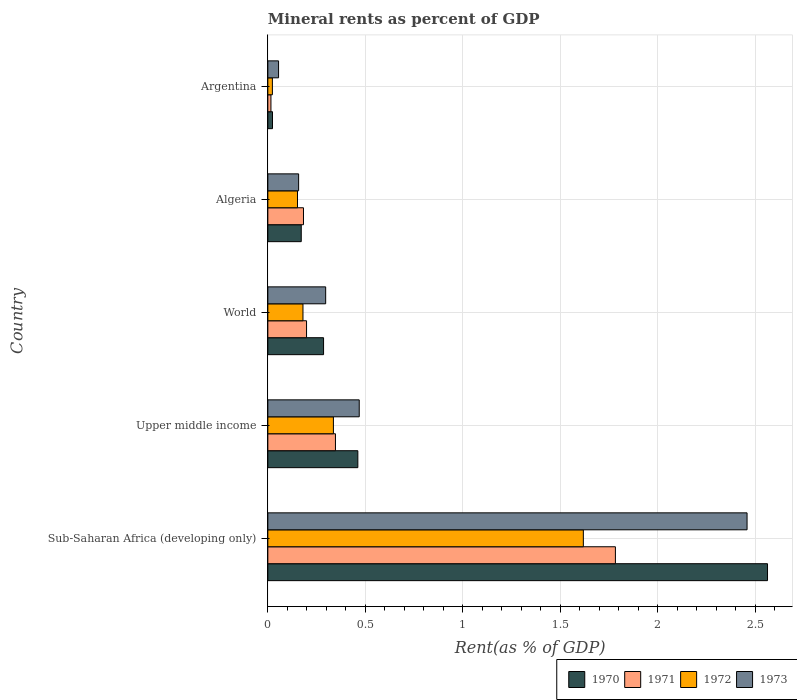How many groups of bars are there?
Your answer should be compact. 5. Are the number of bars per tick equal to the number of legend labels?
Your response must be concise. Yes. How many bars are there on the 5th tick from the top?
Keep it short and to the point. 4. How many bars are there on the 2nd tick from the bottom?
Ensure brevity in your answer.  4. What is the label of the 4th group of bars from the top?
Ensure brevity in your answer.  Upper middle income. What is the mineral rent in 1971 in Sub-Saharan Africa (developing only)?
Your answer should be very brief. 1.78. Across all countries, what is the maximum mineral rent in 1972?
Offer a terse response. 1.62. Across all countries, what is the minimum mineral rent in 1971?
Ensure brevity in your answer.  0.02. In which country was the mineral rent in 1972 maximum?
Give a very brief answer. Sub-Saharan Africa (developing only). In which country was the mineral rent in 1972 minimum?
Provide a succinct answer. Argentina. What is the total mineral rent in 1970 in the graph?
Your answer should be compact. 3.51. What is the difference between the mineral rent in 1971 in Argentina and that in Upper middle income?
Offer a terse response. -0.33. What is the difference between the mineral rent in 1973 in Argentina and the mineral rent in 1971 in World?
Keep it short and to the point. -0.14. What is the average mineral rent in 1970 per country?
Provide a succinct answer. 0.7. What is the difference between the mineral rent in 1972 and mineral rent in 1971 in Argentina?
Keep it short and to the point. 0.01. In how many countries, is the mineral rent in 1970 greater than 1.4 %?
Give a very brief answer. 1. What is the ratio of the mineral rent in 1972 in Sub-Saharan Africa (developing only) to that in Upper middle income?
Offer a very short reply. 4.81. What is the difference between the highest and the second highest mineral rent in 1973?
Offer a very short reply. 1.99. What is the difference between the highest and the lowest mineral rent in 1971?
Make the answer very short. 1.77. Is the sum of the mineral rent in 1973 in Algeria and World greater than the maximum mineral rent in 1972 across all countries?
Ensure brevity in your answer.  No. Is it the case that in every country, the sum of the mineral rent in 1973 and mineral rent in 1971 is greater than the sum of mineral rent in 1972 and mineral rent in 1970?
Provide a short and direct response. No. How many bars are there?
Your response must be concise. 20. Are all the bars in the graph horizontal?
Your response must be concise. Yes. How many countries are there in the graph?
Keep it short and to the point. 5. What is the difference between two consecutive major ticks on the X-axis?
Provide a short and direct response. 0.5. Are the values on the major ticks of X-axis written in scientific E-notation?
Give a very brief answer. No. Where does the legend appear in the graph?
Ensure brevity in your answer.  Bottom right. How many legend labels are there?
Your answer should be very brief. 4. What is the title of the graph?
Offer a terse response. Mineral rents as percent of GDP. What is the label or title of the X-axis?
Your answer should be compact. Rent(as % of GDP). What is the Rent(as % of GDP) of 1970 in Sub-Saharan Africa (developing only)?
Offer a terse response. 2.56. What is the Rent(as % of GDP) of 1971 in Sub-Saharan Africa (developing only)?
Provide a succinct answer. 1.78. What is the Rent(as % of GDP) in 1972 in Sub-Saharan Africa (developing only)?
Offer a terse response. 1.62. What is the Rent(as % of GDP) in 1973 in Sub-Saharan Africa (developing only)?
Offer a very short reply. 2.46. What is the Rent(as % of GDP) of 1970 in Upper middle income?
Offer a very short reply. 0.46. What is the Rent(as % of GDP) in 1971 in Upper middle income?
Your answer should be very brief. 0.35. What is the Rent(as % of GDP) of 1972 in Upper middle income?
Your answer should be very brief. 0.34. What is the Rent(as % of GDP) in 1973 in Upper middle income?
Provide a succinct answer. 0.47. What is the Rent(as % of GDP) in 1970 in World?
Offer a very short reply. 0.29. What is the Rent(as % of GDP) of 1971 in World?
Offer a very short reply. 0.2. What is the Rent(as % of GDP) of 1972 in World?
Make the answer very short. 0.18. What is the Rent(as % of GDP) of 1973 in World?
Offer a terse response. 0.3. What is the Rent(as % of GDP) of 1970 in Algeria?
Keep it short and to the point. 0.17. What is the Rent(as % of GDP) in 1971 in Algeria?
Your answer should be very brief. 0.18. What is the Rent(as % of GDP) in 1972 in Algeria?
Give a very brief answer. 0.15. What is the Rent(as % of GDP) in 1973 in Algeria?
Make the answer very short. 0.16. What is the Rent(as % of GDP) in 1970 in Argentina?
Your answer should be very brief. 0.02. What is the Rent(as % of GDP) in 1971 in Argentina?
Offer a very short reply. 0.02. What is the Rent(as % of GDP) of 1972 in Argentina?
Make the answer very short. 0.02. What is the Rent(as % of GDP) in 1973 in Argentina?
Keep it short and to the point. 0.06. Across all countries, what is the maximum Rent(as % of GDP) in 1970?
Make the answer very short. 2.56. Across all countries, what is the maximum Rent(as % of GDP) of 1971?
Provide a short and direct response. 1.78. Across all countries, what is the maximum Rent(as % of GDP) of 1972?
Keep it short and to the point. 1.62. Across all countries, what is the maximum Rent(as % of GDP) in 1973?
Keep it short and to the point. 2.46. Across all countries, what is the minimum Rent(as % of GDP) in 1970?
Your answer should be very brief. 0.02. Across all countries, what is the minimum Rent(as % of GDP) of 1971?
Ensure brevity in your answer.  0.02. Across all countries, what is the minimum Rent(as % of GDP) of 1972?
Your response must be concise. 0.02. Across all countries, what is the minimum Rent(as % of GDP) in 1973?
Your answer should be very brief. 0.06. What is the total Rent(as % of GDP) in 1970 in the graph?
Keep it short and to the point. 3.51. What is the total Rent(as % of GDP) in 1971 in the graph?
Your answer should be compact. 2.53. What is the total Rent(as % of GDP) of 1972 in the graph?
Provide a succinct answer. 2.31. What is the total Rent(as % of GDP) of 1973 in the graph?
Offer a terse response. 3.44. What is the difference between the Rent(as % of GDP) of 1970 in Sub-Saharan Africa (developing only) and that in Upper middle income?
Give a very brief answer. 2.1. What is the difference between the Rent(as % of GDP) in 1971 in Sub-Saharan Africa (developing only) and that in Upper middle income?
Offer a terse response. 1.44. What is the difference between the Rent(as % of GDP) in 1972 in Sub-Saharan Africa (developing only) and that in Upper middle income?
Give a very brief answer. 1.28. What is the difference between the Rent(as % of GDP) in 1973 in Sub-Saharan Africa (developing only) and that in Upper middle income?
Offer a very short reply. 1.99. What is the difference between the Rent(as % of GDP) in 1970 in Sub-Saharan Africa (developing only) and that in World?
Give a very brief answer. 2.28. What is the difference between the Rent(as % of GDP) in 1971 in Sub-Saharan Africa (developing only) and that in World?
Give a very brief answer. 1.58. What is the difference between the Rent(as % of GDP) in 1972 in Sub-Saharan Africa (developing only) and that in World?
Your response must be concise. 1.44. What is the difference between the Rent(as % of GDP) of 1973 in Sub-Saharan Africa (developing only) and that in World?
Offer a very short reply. 2.16. What is the difference between the Rent(as % of GDP) of 1970 in Sub-Saharan Africa (developing only) and that in Algeria?
Offer a terse response. 2.39. What is the difference between the Rent(as % of GDP) in 1971 in Sub-Saharan Africa (developing only) and that in Algeria?
Ensure brevity in your answer.  1.6. What is the difference between the Rent(as % of GDP) in 1972 in Sub-Saharan Africa (developing only) and that in Algeria?
Ensure brevity in your answer.  1.47. What is the difference between the Rent(as % of GDP) in 1973 in Sub-Saharan Africa (developing only) and that in Algeria?
Offer a very short reply. 2.3. What is the difference between the Rent(as % of GDP) of 1970 in Sub-Saharan Africa (developing only) and that in Argentina?
Offer a very short reply. 2.54. What is the difference between the Rent(as % of GDP) in 1971 in Sub-Saharan Africa (developing only) and that in Argentina?
Keep it short and to the point. 1.77. What is the difference between the Rent(as % of GDP) in 1972 in Sub-Saharan Africa (developing only) and that in Argentina?
Your answer should be compact. 1.6. What is the difference between the Rent(as % of GDP) in 1973 in Sub-Saharan Africa (developing only) and that in Argentina?
Offer a terse response. 2.4. What is the difference between the Rent(as % of GDP) in 1970 in Upper middle income and that in World?
Provide a short and direct response. 0.18. What is the difference between the Rent(as % of GDP) of 1971 in Upper middle income and that in World?
Your answer should be very brief. 0.15. What is the difference between the Rent(as % of GDP) of 1972 in Upper middle income and that in World?
Keep it short and to the point. 0.16. What is the difference between the Rent(as % of GDP) of 1973 in Upper middle income and that in World?
Your answer should be very brief. 0.17. What is the difference between the Rent(as % of GDP) of 1970 in Upper middle income and that in Algeria?
Ensure brevity in your answer.  0.29. What is the difference between the Rent(as % of GDP) in 1971 in Upper middle income and that in Algeria?
Your answer should be very brief. 0.16. What is the difference between the Rent(as % of GDP) of 1972 in Upper middle income and that in Algeria?
Your answer should be compact. 0.18. What is the difference between the Rent(as % of GDP) in 1973 in Upper middle income and that in Algeria?
Your answer should be compact. 0.31. What is the difference between the Rent(as % of GDP) in 1970 in Upper middle income and that in Argentina?
Your response must be concise. 0.44. What is the difference between the Rent(as % of GDP) in 1971 in Upper middle income and that in Argentina?
Provide a succinct answer. 0.33. What is the difference between the Rent(as % of GDP) of 1972 in Upper middle income and that in Argentina?
Ensure brevity in your answer.  0.31. What is the difference between the Rent(as % of GDP) of 1973 in Upper middle income and that in Argentina?
Provide a succinct answer. 0.41. What is the difference between the Rent(as % of GDP) in 1970 in World and that in Algeria?
Make the answer very short. 0.11. What is the difference between the Rent(as % of GDP) of 1971 in World and that in Algeria?
Keep it short and to the point. 0.02. What is the difference between the Rent(as % of GDP) in 1972 in World and that in Algeria?
Provide a short and direct response. 0.03. What is the difference between the Rent(as % of GDP) of 1973 in World and that in Algeria?
Make the answer very short. 0.14. What is the difference between the Rent(as % of GDP) of 1970 in World and that in Argentina?
Your response must be concise. 0.26. What is the difference between the Rent(as % of GDP) of 1971 in World and that in Argentina?
Offer a very short reply. 0.18. What is the difference between the Rent(as % of GDP) of 1972 in World and that in Argentina?
Offer a terse response. 0.16. What is the difference between the Rent(as % of GDP) of 1973 in World and that in Argentina?
Make the answer very short. 0.24. What is the difference between the Rent(as % of GDP) in 1970 in Algeria and that in Argentina?
Your answer should be very brief. 0.15. What is the difference between the Rent(as % of GDP) in 1971 in Algeria and that in Argentina?
Ensure brevity in your answer.  0.17. What is the difference between the Rent(as % of GDP) of 1972 in Algeria and that in Argentina?
Provide a short and direct response. 0.13. What is the difference between the Rent(as % of GDP) of 1973 in Algeria and that in Argentina?
Your answer should be compact. 0.1. What is the difference between the Rent(as % of GDP) in 1970 in Sub-Saharan Africa (developing only) and the Rent(as % of GDP) in 1971 in Upper middle income?
Your answer should be compact. 2.22. What is the difference between the Rent(as % of GDP) in 1970 in Sub-Saharan Africa (developing only) and the Rent(as % of GDP) in 1972 in Upper middle income?
Provide a succinct answer. 2.23. What is the difference between the Rent(as % of GDP) of 1970 in Sub-Saharan Africa (developing only) and the Rent(as % of GDP) of 1973 in Upper middle income?
Offer a very short reply. 2.1. What is the difference between the Rent(as % of GDP) in 1971 in Sub-Saharan Africa (developing only) and the Rent(as % of GDP) in 1972 in Upper middle income?
Provide a short and direct response. 1.45. What is the difference between the Rent(as % of GDP) of 1971 in Sub-Saharan Africa (developing only) and the Rent(as % of GDP) of 1973 in Upper middle income?
Your response must be concise. 1.31. What is the difference between the Rent(as % of GDP) in 1972 in Sub-Saharan Africa (developing only) and the Rent(as % of GDP) in 1973 in Upper middle income?
Ensure brevity in your answer.  1.15. What is the difference between the Rent(as % of GDP) in 1970 in Sub-Saharan Africa (developing only) and the Rent(as % of GDP) in 1971 in World?
Your answer should be compact. 2.37. What is the difference between the Rent(as % of GDP) of 1970 in Sub-Saharan Africa (developing only) and the Rent(as % of GDP) of 1972 in World?
Provide a succinct answer. 2.38. What is the difference between the Rent(as % of GDP) of 1970 in Sub-Saharan Africa (developing only) and the Rent(as % of GDP) of 1973 in World?
Provide a short and direct response. 2.27. What is the difference between the Rent(as % of GDP) of 1971 in Sub-Saharan Africa (developing only) and the Rent(as % of GDP) of 1972 in World?
Offer a very short reply. 1.6. What is the difference between the Rent(as % of GDP) in 1971 in Sub-Saharan Africa (developing only) and the Rent(as % of GDP) in 1973 in World?
Your answer should be compact. 1.49. What is the difference between the Rent(as % of GDP) of 1972 in Sub-Saharan Africa (developing only) and the Rent(as % of GDP) of 1973 in World?
Give a very brief answer. 1.32. What is the difference between the Rent(as % of GDP) in 1970 in Sub-Saharan Africa (developing only) and the Rent(as % of GDP) in 1971 in Algeria?
Make the answer very short. 2.38. What is the difference between the Rent(as % of GDP) in 1970 in Sub-Saharan Africa (developing only) and the Rent(as % of GDP) in 1972 in Algeria?
Offer a very short reply. 2.41. What is the difference between the Rent(as % of GDP) of 1970 in Sub-Saharan Africa (developing only) and the Rent(as % of GDP) of 1973 in Algeria?
Offer a terse response. 2.41. What is the difference between the Rent(as % of GDP) in 1971 in Sub-Saharan Africa (developing only) and the Rent(as % of GDP) in 1972 in Algeria?
Your answer should be very brief. 1.63. What is the difference between the Rent(as % of GDP) in 1971 in Sub-Saharan Africa (developing only) and the Rent(as % of GDP) in 1973 in Algeria?
Your answer should be very brief. 1.63. What is the difference between the Rent(as % of GDP) of 1972 in Sub-Saharan Africa (developing only) and the Rent(as % of GDP) of 1973 in Algeria?
Keep it short and to the point. 1.46. What is the difference between the Rent(as % of GDP) in 1970 in Sub-Saharan Africa (developing only) and the Rent(as % of GDP) in 1971 in Argentina?
Your answer should be compact. 2.55. What is the difference between the Rent(as % of GDP) of 1970 in Sub-Saharan Africa (developing only) and the Rent(as % of GDP) of 1972 in Argentina?
Provide a succinct answer. 2.54. What is the difference between the Rent(as % of GDP) in 1970 in Sub-Saharan Africa (developing only) and the Rent(as % of GDP) in 1973 in Argentina?
Provide a succinct answer. 2.51. What is the difference between the Rent(as % of GDP) of 1971 in Sub-Saharan Africa (developing only) and the Rent(as % of GDP) of 1972 in Argentina?
Your answer should be very brief. 1.76. What is the difference between the Rent(as % of GDP) of 1971 in Sub-Saharan Africa (developing only) and the Rent(as % of GDP) of 1973 in Argentina?
Offer a very short reply. 1.73. What is the difference between the Rent(as % of GDP) in 1972 in Sub-Saharan Africa (developing only) and the Rent(as % of GDP) in 1973 in Argentina?
Give a very brief answer. 1.56. What is the difference between the Rent(as % of GDP) of 1970 in Upper middle income and the Rent(as % of GDP) of 1971 in World?
Provide a short and direct response. 0.26. What is the difference between the Rent(as % of GDP) of 1970 in Upper middle income and the Rent(as % of GDP) of 1972 in World?
Provide a succinct answer. 0.28. What is the difference between the Rent(as % of GDP) of 1970 in Upper middle income and the Rent(as % of GDP) of 1973 in World?
Your answer should be very brief. 0.17. What is the difference between the Rent(as % of GDP) of 1971 in Upper middle income and the Rent(as % of GDP) of 1972 in World?
Your answer should be very brief. 0.17. What is the difference between the Rent(as % of GDP) of 1971 in Upper middle income and the Rent(as % of GDP) of 1973 in World?
Ensure brevity in your answer.  0.05. What is the difference between the Rent(as % of GDP) of 1972 in Upper middle income and the Rent(as % of GDP) of 1973 in World?
Offer a very short reply. 0.04. What is the difference between the Rent(as % of GDP) in 1970 in Upper middle income and the Rent(as % of GDP) in 1971 in Algeria?
Offer a very short reply. 0.28. What is the difference between the Rent(as % of GDP) in 1970 in Upper middle income and the Rent(as % of GDP) in 1972 in Algeria?
Make the answer very short. 0.31. What is the difference between the Rent(as % of GDP) of 1970 in Upper middle income and the Rent(as % of GDP) of 1973 in Algeria?
Ensure brevity in your answer.  0.3. What is the difference between the Rent(as % of GDP) of 1971 in Upper middle income and the Rent(as % of GDP) of 1972 in Algeria?
Your answer should be compact. 0.19. What is the difference between the Rent(as % of GDP) in 1971 in Upper middle income and the Rent(as % of GDP) in 1973 in Algeria?
Offer a terse response. 0.19. What is the difference between the Rent(as % of GDP) in 1972 in Upper middle income and the Rent(as % of GDP) in 1973 in Algeria?
Offer a very short reply. 0.18. What is the difference between the Rent(as % of GDP) in 1970 in Upper middle income and the Rent(as % of GDP) in 1971 in Argentina?
Keep it short and to the point. 0.45. What is the difference between the Rent(as % of GDP) of 1970 in Upper middle income and the Rent(as % of GDP) of 1972 in Argentina?
Keep it short and to the point. 0.44. What is the difference between the Rent(as % of GDP) in 1970 in Upper middle income and the Rent(as % of GDP) in 1973 in Argentina?
Your answer should be compact. 0.41. What is the difference between the Rent(as % of GDP) in 1971 in Upper middle income and the Rent(as % of GDP) in 1972 in Argentina?
Give a very brief answer. 0.32. What is the difference between the Rent(as % of GDP) in 1971 in Upper middle income and the Rent(as % of GDP) in 1973 in Argentina?
Keep it short and to the point. 0.29. What is the difference between the Rent(as % of GDP) of 1972 in Upper middle income and the Rent(as % of GDP) of 1973 in Argentina?
Ensure brevity in your answer.  0.28. What is the difference between the Rent(as % of GDP) in 1970 in World and the Rent(as % of GDP) in 1971 in Algeria?
Ensure brevity in your answer.  0.1. What is the difference between the Rent(as % of GDP) of 1970 in World and the Rent(as % of GDP) of 1972 in Algeria?
Provide a short and direct response. 0.13. What is the difference between the Rent(as % of GDP) of 1970 in World and the Rent(as % of GDP) of 1973 in Algeria?
Provide a succinct answer. 0.13. What is the difference between the Rent(as % of GDP) of 1971 in World and the Rent(as % of GDP) of 1972 in Algeria?
Your answer should be compact. 0.05. What is the difference between the Rent(as % of GDP) of 1971 in World and the Rent(as % of GDP) of 1973 in Algeria?
Make the answer very short. 0.04. What is the difference between the Rent(as % of GDP) of 1972 in World and the Rent(as % of GDP) of 1973 in Algeria?
Your answer should be very brief. 0.02. What is the difference between the Rent(as % of GDP) of 1970 in World and the Rent(as % of GDP) of 1971 in Argentina?
Your answer should be very brief. 0.27. What is the difference between the Rent(as % of GDP) in 1970 in World and the Rent(as % of GDP) in 1972 in Argentina?
Your response must be concise. 0.26. What is the difference between the Rent(as % of GDP) in 1970 in World and the Rent(as % of GDP) in 1973 in Argentina?
Make the answer very short. 0.23. What is the difference between the Rent(as % of GDP) in 1971 in World and the Rent(as % of GDP) in 1972 in Argentina?
Keep it short and to the point. 0.18. What is the difference between the Rent(as % of GDP) in 1971 in World and the Rent(as % of GDP) in 1973 in Argentina?
Keep it short and to the point. 0.14. What is the difference between the Rent(as % of GDP) in 1972 in World and the Rent(as % of GDP) in 1973 in Argentina?
Provide a succinct answer. 0.13. What is the difference between the Rent(as % of GDP) in 1970 in Algeria and the Rent(as % of GDP) in 1971 in Argentina?
Give a very brief answer. 0.16. What is the difference between the Rent(as % of GDP) of 1970 in Algeria and the Rent(as % of GDP) of 1972 in Argentina?
Your answer should be very brief. 0.15. What is the difference between the Rent(as % of GDP) in 1970 in Algeria and the Rent(as % of GDP) in 1973 in Argentina?
Make the answer very short. 0.12. What is the difference between the Rent(as % of GDP) of 1971 in Algeria and the Rent(as % of GDP) of 1972 in Argentina?
Make the answer very short. 0.16. What is the difference between the Rent(as % of GDP) in 1971 in Algeria and the Rent(as % of GDP) in 1973 in Argentina?
Provide a succinct answer. 0.13. What is the difference between the Rent(as % of GDP) in 1972 in Algeria and the Rent(as % of GDP) in 1973 in Argentina?
Your answer should be very brief. 0.1. What is the average Rent(as % of GDP) in 1970 per country?
Provide a succinct answer. 0.7. What is the average Rent(as % of GDP) in 1971 per country?
Make the answer very short. 0.51. What is the average Rent(as % of GDP) of 1972 per country?
Keep it short and to the point. 0.46. What is the average Rent(as % of GDP) in 1973 per country?
Your answer should be very brief. 0.69. What is the difference between the Rent(as % of GDP) in 1970 and Rent(as % of GDP) in 1971 in Sub-Saharan Africa (developing only)?
Offer a terse response. 0.78. What is the difference between the Rent(as % of GDP) of 1970 and Rent(as % of GDP) of 1972 in Sub-Saharan Africa (developing only)?
Ensure brevity in your answer.  0.95. What is the difference between the Rent(as % of GDP) in 1970 and Rent(as % of GDP) in 1973 in Sub-Saharan Africa (developing only)?
Your response must be concise. 0.1. What is the difference between the Rent(as % of GDP) in 1971 and Rent(as % of GDP) in 1972 in Sub-Saharan Africa (developing only)?
Offer a very short reply. 0.16. What is the difference between the Rent(as % of GDP) in 1971 and Rent(as % of GDP) in 1973 in Sub-Saharan Africa (developing only)?
Your answer should be compact. -0.68. What is the difference between the Rent(as % of GDP) of 1972 and Rent(as % of GDP) of 1973 in Sub-Saharan Africa (developing only)?
Give a very brief answer. -0.84. What is the difference between the Rent(as % of GDP) in 1970 and Rent(as % of GDP) in 1971 in Upper middle income?
Keep it short and to the point. 0.11. What is the difference between the Rent(as % of GDP) of 1970 and Rent(as % of GDP) of 1972 in Upper middle income?
Your answer should be very brief. 0.13. What is the difference between the Rent(as % of GDP) of 1970 and Rent(as % of GDP) of 1973 in Upper middle income?
Provide a succinct answer. -0.01. What is the difference between the Rent(as % of GDP) of 1971 and Rent(as % of GDP) of 1972 in Upper middle income?
Offer a terse response. 0.01. What is the difference between the Rent(as % of GDP) in 1971 and Rent(as % of GDP) in 1973 in Upper middle income?
Keep it short and to the point. -0.12. What is the difference between the Rent(as % of GDP) in 1972 and Rent(as % of GDP) in 1973 in Upper middle income?
Your answer should be compact. -0.13. What is the difference between the Rent(as % of GDP) in 1970 and Rent(as % of GDP) in 1971 in World?
Your response must be concise. 0.09. What is the difference between the Rent(as % of GDP) in 1970 and Rent(as % of GDP) in 1972 in World?
Your answer should be compact. 0.11. What is the difference between the Rent(as % of GDP) in 1970 and Rent(as % of GDP) in 1973 in World?
Ensure brevity in your answer.  -0.01. What is the difference between the Rent(as % of GDP) in 1971 and Rent(as % of GDP) in 1972 in World?
Ensure brevity in your answer.  0.02. What is the difference between the Rent(as % of GDP) of 1971 and Rent(as % of GDP) of 1973 in World?
Ensure brevity in your answer.  -0.1. What is the difference between the Rent(as % of GDP) in 1972 and Rent(as % of GDP) in 1973 in World?
Make the answer very short. -0.12. What is the difference between the Rent(as % of GDP) of 1970 and Rent(as % of GDP) of 1971 in Algeria?
Your response must be concise. -0.01. What is the difference between the Rent(as % of GDP) in 1970 and Rent(as % of GDP) in 1972 in Algeria?
Your response must be concise. 0.02. What is the difference between the Rent(as % of GDP) of 1970 and Rent(as % of GDP) of 1973 in Algeria?
Give a very brief answer. 0.01. What is the difference between the Rent(as % of GDP) of 1971 and Rent(as % of GDP) of 1972 in Algeria?
Your answer should be very brief. 0.03. What is the difference between the Rent(as % of GDP) of 1971 and Rent(as % of GDP) of 1973 in Algeria?
Your answer should be compact. 0.03. What is the difference between the Rent(as % of GDP) of 1972 and Rent(as % of GDP) of 1973 in Algeria?
Make the answer very short. -0.01. What is the difference between the Rent(as % of GDP) in 1970 and Rent(as % of GDP) in 1971 in Argentina?
Make the answer very short. 0.01. What is the difference between the Rent(as % of GDP) of 1970 and Rent(as % of GDP) of 1972 in Argentina?
Your response must be concise. 0. What is the difference between the Rent(as % of GDP) in 1970 and Rent(as % of GDP) in 1973 in Argentina?
Provide a short and direct response. -0.03. What is the difference between the Rent(as % of GDP) in 1971 and Rent(as % of GDP) in 1972 in Argentina?
Provide a succinct answer. -0.01. What is the difference between the Rent(as % of GDP) of 1971 and Rent(as % of GDP) of 1973 in Argentina?
Provide a succinct answer. -0.04. What is the difference between the Rent(as % of GDP) in 1972 and Rent(as % of GDP) in 1973 in Argentina?
Your answer should be compact. -0.03. What is the ratio of the Rent(as % of GDP) of 1970 in Sub-Saharan Africa (developing only) to that in Upper middle income?
Your answer should be compact. 5.55. What is the ratio of the Rent(as % of GDP) of 1971 in Sub-Saharan Africa (developing only) to that in Upper middle income?
Give a very brief answer. 5.14. What is the ratio of the Rent(as % of GDP) of 1972 in Sub-Saharan Africa (developing only) to that in Upper middle income?
Provide a short and direct response. 4.81. What is the ratio of the Rent(as % of GDP) of 1973 in Sub-Saharan Africa (developing only) to that in Upper middle income?
Provide a short and direct response. 5.24. What is the ratio of the Rent(as % of GDP) of 1970 in Sub-Saharan Africa (developing only) to that in World?
Give a very brief answer. 8.97. What is the ratio of the Rent(as % of GDP) of 1971 in Sub-Saharan Africa (developing only) to that in World?
Provide a succinct answer. 8.98. What is the ratio of the Rent(as % of GDP) in 1972 in Sub-Saharan Africa (developing only) to that in World?
Your answer should be very brief. 8.98. What is the ratio of the Rent(as % of GDP) of 1973 in Sub-Saharan Africa (developing only) to that in World?
Give a very brief answer. 8.29. What is the ratio of the Rent(as % of GDP) of 1970 in Sub-Saharan Africa (developing only) to that in Algeria?
Your answer should be very brief. 14.96. What is the ratio of the Rent(as % of GDP) of 1971 in Sub-Saharan Africa (developing only) to that in Algeria?
Your answer should be compact. 9.75. What is the ratio of the Rent(as % of GDP) in 1972 in Sub-Saharan Africa (developing only) to that in Algeria?
Offer a terse response. 10.64. What is the ratio of the Rent(as % of GDP) of 1973 in Sub-Saharan Africa (developing only) to that in Algeria?
Make the answer very short. 15.57. What is the ratio of the Rent(as % of GDP) of 1970 in Sub-Saharan Africa (developing only) to that in Argentina?
Keep it short and to the point. 107.21. What is the ratio of the Rent(as % of GDP) of 1971 in Sub-Saharan Africa (developing only) to that in Argentina?
Your answer should be very brief. 112.17. What is the ratio of the Rent(as % of GDP) in 1972 in Sub-Saharan Africa (developing only) to that in Argentina?
Give a very brief answer. 69.45. What is the ratio of the Rent(as % of GDP) in 1973 in Sub-Saharan Africa (developing only) to that in Argentina?
Offer a very short reply. 44.71. What is the ratio of the Rent(as % of GDP) in 1970 in Upper middle income to that in World?
Your response must be concise. 1.62. What is the ratio of the Rent(as % of GDP) in 1971 in Upper middle income to that in World?
Ensure brevity in your answer.  1.75. What is the ratio of the Rent(as % of GDP) of 1972 in Upper middle income to that in World?
Offer a very short reply. 1.87. What is the ratio of the Rent(as % of GDP) in 1973 in Upper middle income to that in World?
Ensure brevity in your answer.  1.58. What is the ratio of the Rent(as % of GDP) in 1970 in Upper middle income to that in Algeria?
Your answer should be compact. 2.69. What is the ratio of the Rent(as % of GDP) of 1971 in Upper middle income to that in Algeria?
Your response must be concise. 1.9. What is the ratio of the Rent(as % of GDP) in 1972 in Upper middle income to that in Algeria?
Your answer should be compact. 2.21. What is the ratio of the Rent(as % of GDP) of 1973 in Upper middle income to that in Algeria?
Make the answer very short. 2.97. What is the ratio of the Rent(as % of GDP) in 1970 in Upper middle income to that in Argentina?
Provide a short and direct response. 19.31. What is the ratio of the Rent(as % of GDP) of 1971 in Upper middle income to that in Argentina?
Your answer should be compact. 21.82. What is the ratio of the Rent(as % of GDP) in 1972 in Upper middle income to that in Argentina?
Your answer should be very brief. 14.43. What is the ratio of the Rent(as % of GDP) of 1973 in Upper middle income to that in Argentina?
Offer a very short reply. 8.53. What is the ratio of the Rent(as % of GDP) of 1970 in World to that in Algeria?
Your response must be concise. 1.67. What is the ratio of the Rent(as % of GDP) in 1971 in World to that in Algeria?
Give a very brief answer. 1.09. What is the ratio of the Rent(as % of GDP) in 1972 in World to that in Algeria?
Your answer should be very brief. 1.18. What is the ratio of the Rent(as % of GDP) in 1973 in World to that in Algeria?
Your answer should be compact. 1.88. What is the ratio of the Rent(as % of GDP) of 1970 in World to that in Argentina?
Your answer should be compact. 11.96. What is the ratio of the Rent(as % of GDP) of 1971 in World to that in Argentina?
Your answer should be compact. 12.49. What is the ratio of the Rent(as % of GDP) in 1972 in World to that in Argentina?
Make the answer very short. 7.73. What is the ratio of the Rent(as % of GDP) of 1973 in World to that in Argentina?
Make the answer very short. 5.4. What is the ratio of the Rent(as % of GDP) of 1970 in Algeria to that in Argentina?
Provide a short and direct response. 7.17. What is the ratio of the Rent(as % of GDP) of 1971 in Algeria to that in Argentina?
Ensure brevity in your answer.  11.5. What is the ratio of the Rent(as % of GDP) of 1972 in Algeria to that in Argentina?
Offer a very short reply. 6.53. What is the ratio of the Rent(as % of GDP) in 1973 in Algeria to that in Argentina?
Offer a very short reply. 2.87. What is the difference between the highest and the second highest Rent(as % of GDP) in 1970?
Make the answer very short. 2.1. What is the difference between the highest and the second highest Rent(as % of GDP) in 1971?
Make the answer very short. 1.44. What is the difference between the highest and the second highest Rent(as % of GDP) in 1972?
Your response must be concise. 1.28. What is the difference between the highest and the second highest Rent(as % of GDP) in 1973?
Give a very brief answer. 1.99. What is the difference between the highest and the lowest Rent(as % of GDP) of 1970?
Your answer should be compact. 2.54. What is the difference between the highest and the lowest Rent(as % of GDP) of 1971?
Offer a terse response. 1.77. What is the difference between the highest and the lowest Rent(as % of GDP) of 1972?
Provide a succinct answer. 1.6. What is the difference between the highest and the lowest Rent(as % of GDP) in 1973?
Your answer should be very brief. 2.4. 